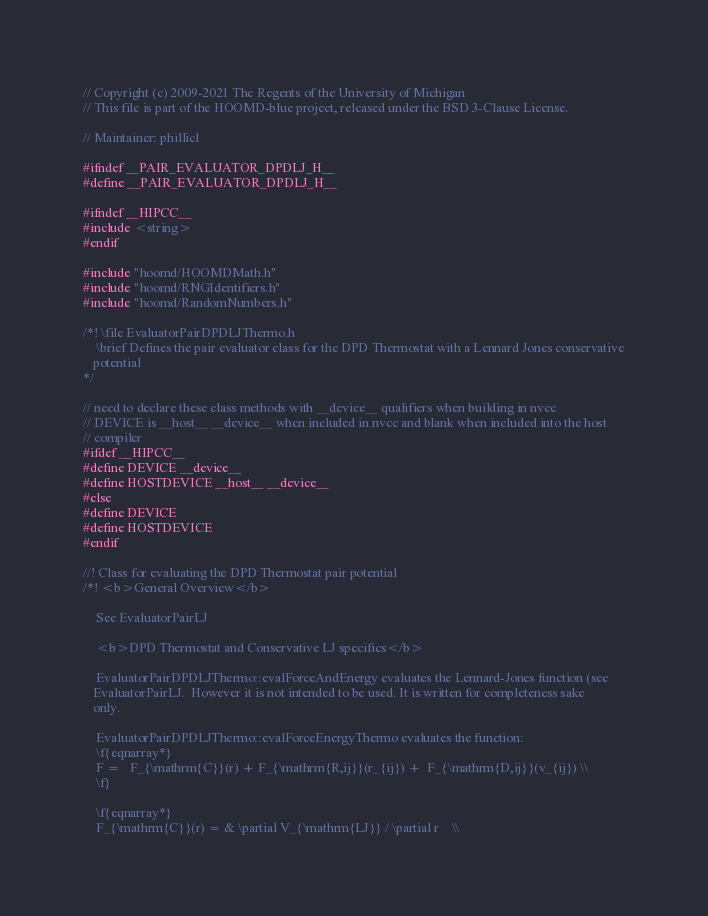Convert code to text. <code><loc_0><loc_0><loc_500><loc_500><_C_>// Copyright (c) 2009-2021 The Regents of the University of Michigan
// This file is part of the HOOMD-blue project, released under the BSD 3-Clause License.

// Maintainer: phillicl

#ifndef __PAIR_EVALUATOR_DPDLJ_H__
#define __PAIR_EVALUATOR_DPDLJ_H__

#ifndef __HIPCC__
#include <string>
#endif

#include "hoomd/HOOMDMath.h"
#include "hoomd/RNGIdentifiers.h"
#include "hoomd/RandomNumbers.h"

/*! \file EvaluatorPairDPDLJThermo.h
    \brief Defines the pair evaluator class for the DPD Thermostat with a Lennard Jones conservative
   potential
*/

// need to declare these class methods with __device__ qualifiers when building in nvcc
// DEVICE is __host__ __device__ when included in nvcc and blank when included into the host
// compiler
#ifdef __HIPCC__
#define DEVICE __device__
#define HOSTDEVICE __host__ __device__
#else
#define DEVICE
#define HOSTDEVICE
#endif

//! Class for evaluating the DPD Thermostat pair potential
/*! <b>General Overview</b>

    See EvaluatorPairLJ

    <b>DPD Thermostat and Conservative LJ specifics</b>

    EvaluatorPairDPDLJThermo::evalForceAndEnergy evaluates the Lennard-Jones function (see
   EvaluatorPairLJ.  However it is not intended to be used. It is written for completeness sake
   only.

    EvaluatorPairDPDLJThermo::evalForceEnergyThermo evaluates the function:
    \f{eqnarray*}
    F =   F_{\mathrm{C}}(r) + F_{\mathrm{R,ij}}(r_{ij}) +  F_{\mathrm{D,ij}}(v_{ij}) \\
    \f}

    \f{eqnarray*}
    F_{\mathrm{C}}(r) = & \partial V_{\mathrm{LJ}} / \partial r    \\</code> 